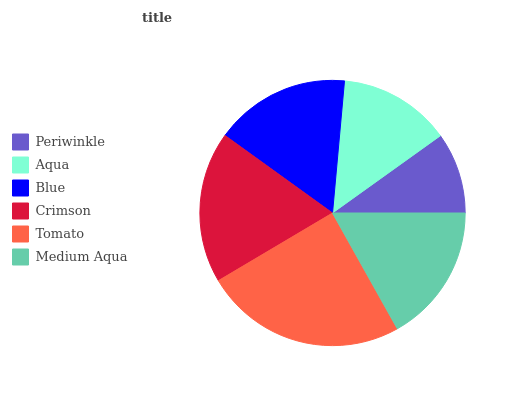Is Periwinkle the minimum?
Answer yes or no. Yes. Is Tomato the maximum?
Answer yes or no. Yes. Is Aqua the minimum?
Answer yes or no. No. Is Aqua the maximum?
Answer yes or no. No. Is Aqua greater than Periwinkle?
Answer yes or no. Yes. Is Periwinkle less than Aqua?
Answer yes or no. Yes. Is Periwinkle greater than Aqua?
Answer yes or no. No. Is Aqua less than Periwinkle?
Answer yes or no. No. Is Medium Aqua the high median?
Answer yes or no. Yes. Is Blue the low median?
Answer yes or no. Yes. Is Tomato the high median?
Answer yes or no. No. Is Crimson the low median?
Answer yes or no. No. 